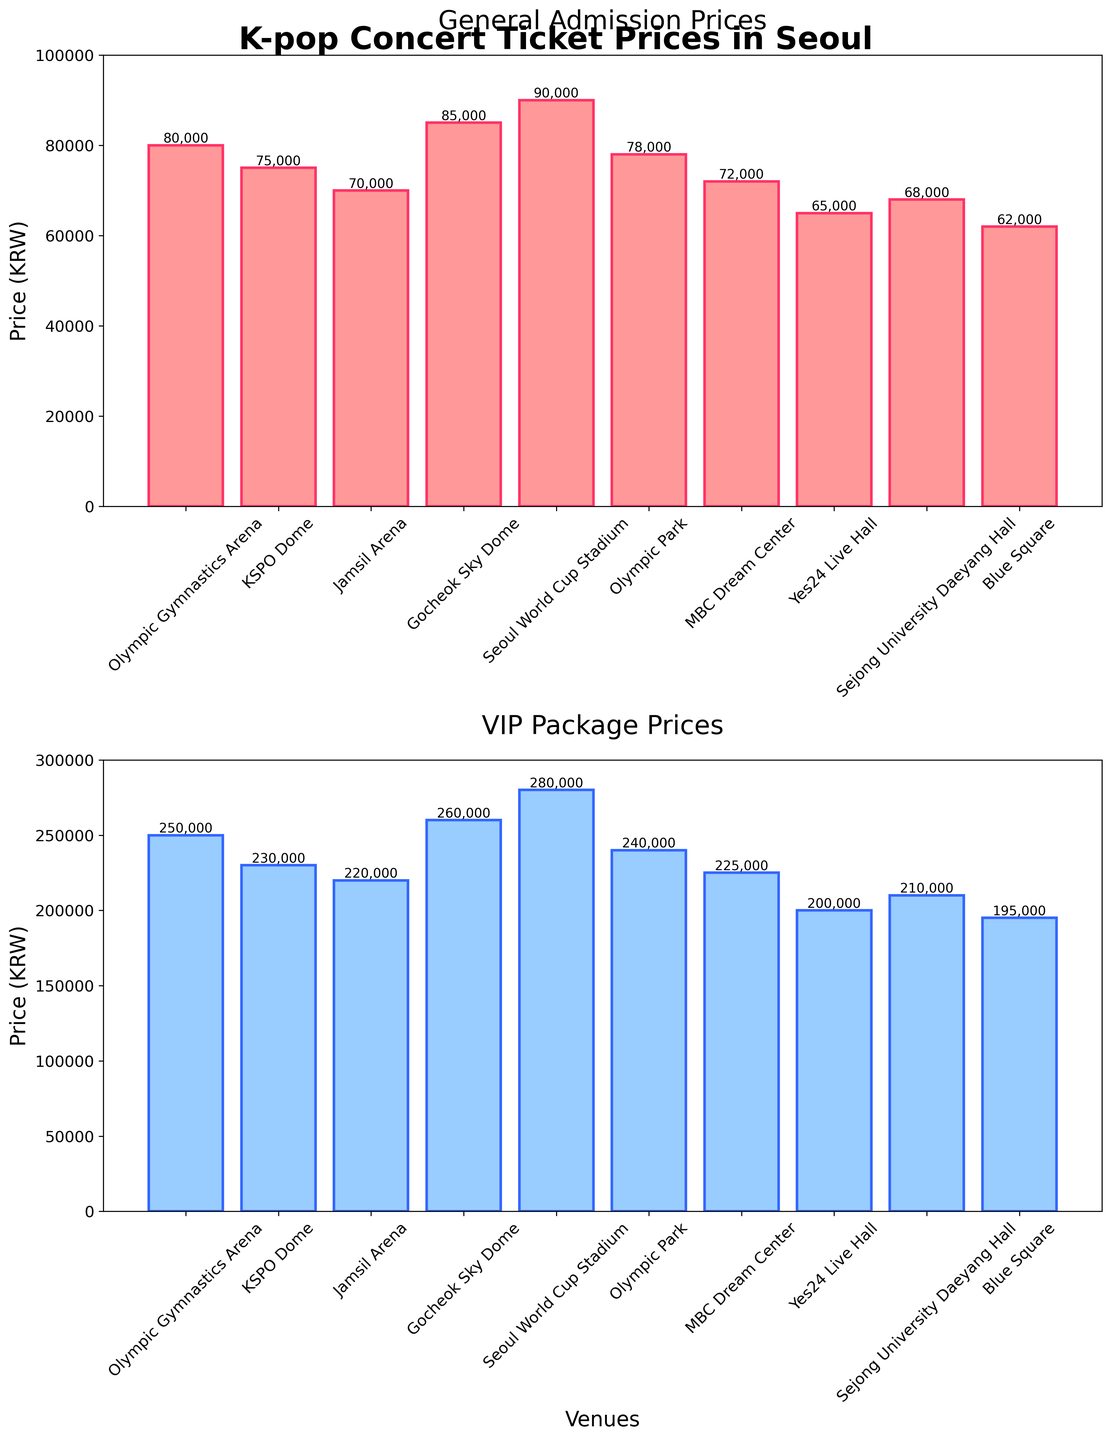What's the highest General Admission price and which venue offers it? The highest bar for General Admission is at Seoul World Cup Stadium, which has a price of 90,000 KRW.
Answer: 90,000 KRW, Seoul World Cup Stadium What's the price difference between General Admission at Olympic Gymnastics Arena and VIP at the same venue? General Admission at Olympic Gymnastics Arena costs 80,000 KRW and the VIP package is 250,000 KRW. The difference is 250,000 - 80,000 = 170,000 KRW.
Answer: 170,000 KRW Which venue has the lowest General Admission price and what is it? The shortest bar in the General Admission plot corresponds to Blue Square, which has a price of 62,000 KRW.
Answer: 62,000 KRW, Blue Square Which venue's VIP package is closest in price to the General Admission at Seoul World Cup Stadium? The General Admission price at Seoul World Cup Stadium is 90,000 KRW. The VIP packages are: 250,000, 230,000, 220,000, 260,000, 280,000, 240,000, 225,000, 200,000, 210,000, and 195,000. The closest price is 200,000 KRW at Yes24 Live Hall.
Answer: Yes24 Live Hall Is there any venue where the General Admission price is more than 75,000 KRW but less than 85,000 KRW? If so, name it. The General Admission prices are 80,000, 75,000, 70,000, 85,000, 90,000, 78,000, 72,000, 65,000, 68,000, and 62,000 KRW. Both Olympic Gymnastics Arena (80,000 KRW) and Olympic Park (78,000 KRW) fit this range.
Answer: Olympic Gymnastics Arena, Olympic Park For which venue is the difference between General Admission and VIP Package the smallest? To find the smallest difference, calculate for each venue:
- Olympic Gymnastics Arena: 250,000 - 80,000 = 170,000
- KSPO Dome: 230,000 - 75,000 = 155,000
- Jamsil Arena: 220,000 - 70,000 = 150,000
- Gocheok Sky Dome: 260,000 - 85,000 = 175,000
- Seoul World Cup Stadium: 280,000 - 90,000 = 190,000
- Olympic Park: 240,000 - 78,000 = 162,000
- MBC Dream Center: 225,000 - 72,000 = 153,000
- Yes24 Live Hall: 200,000 - 65,000 = 135,000
- Sejong University Daeyang Hall: 210,000 - 68,000 = 142,000
- Blue Square: 195,000 - 62,000 = 133,000
The smallest difference is 133,000 KRW at Blue Square.
Answer: Blue Square What is the mean price for General Admission across all venues? Sum the General Admission prices: 80,000 + 75,000 + 70,000 + 85,000 + 90,000 + 78,000 + 72,000 + 65,000 + 68,000 + 62,000 = 745,000. There are 10 venues, so the mean price is 745,000 / 10 = 74,500 KRW.
Answer: 74,500 KRW Which venue shows the greatest visual disparity between General Admission and VIP Package prices, and what are those prices? The most significant visual disparity is indicated by the venue with the largest gap between bar heights in the two plots. Seoul World Cup Stadium has the largest difference, with General Admission at 90,000 KRW and VIP at 280,000 KRW.
Answer: Seoul World Cup Stadium, 90,000 KRW (General), 280,000 KRW (VIP) Compare the General Admission price at KSPO Dome and Jamsil Arena. Which one is more expensive and by how much? General Admission at KSPO Dome is 75,000 KRW, and at Jamsil Arena, it is 70,000 KRW. The difference is 75,000 - 70,000 = 5,000 KRW. KSPO Dome is more expensive by 5,000 KRW.
Answer: KSPO Dome, 5,000 KRW 